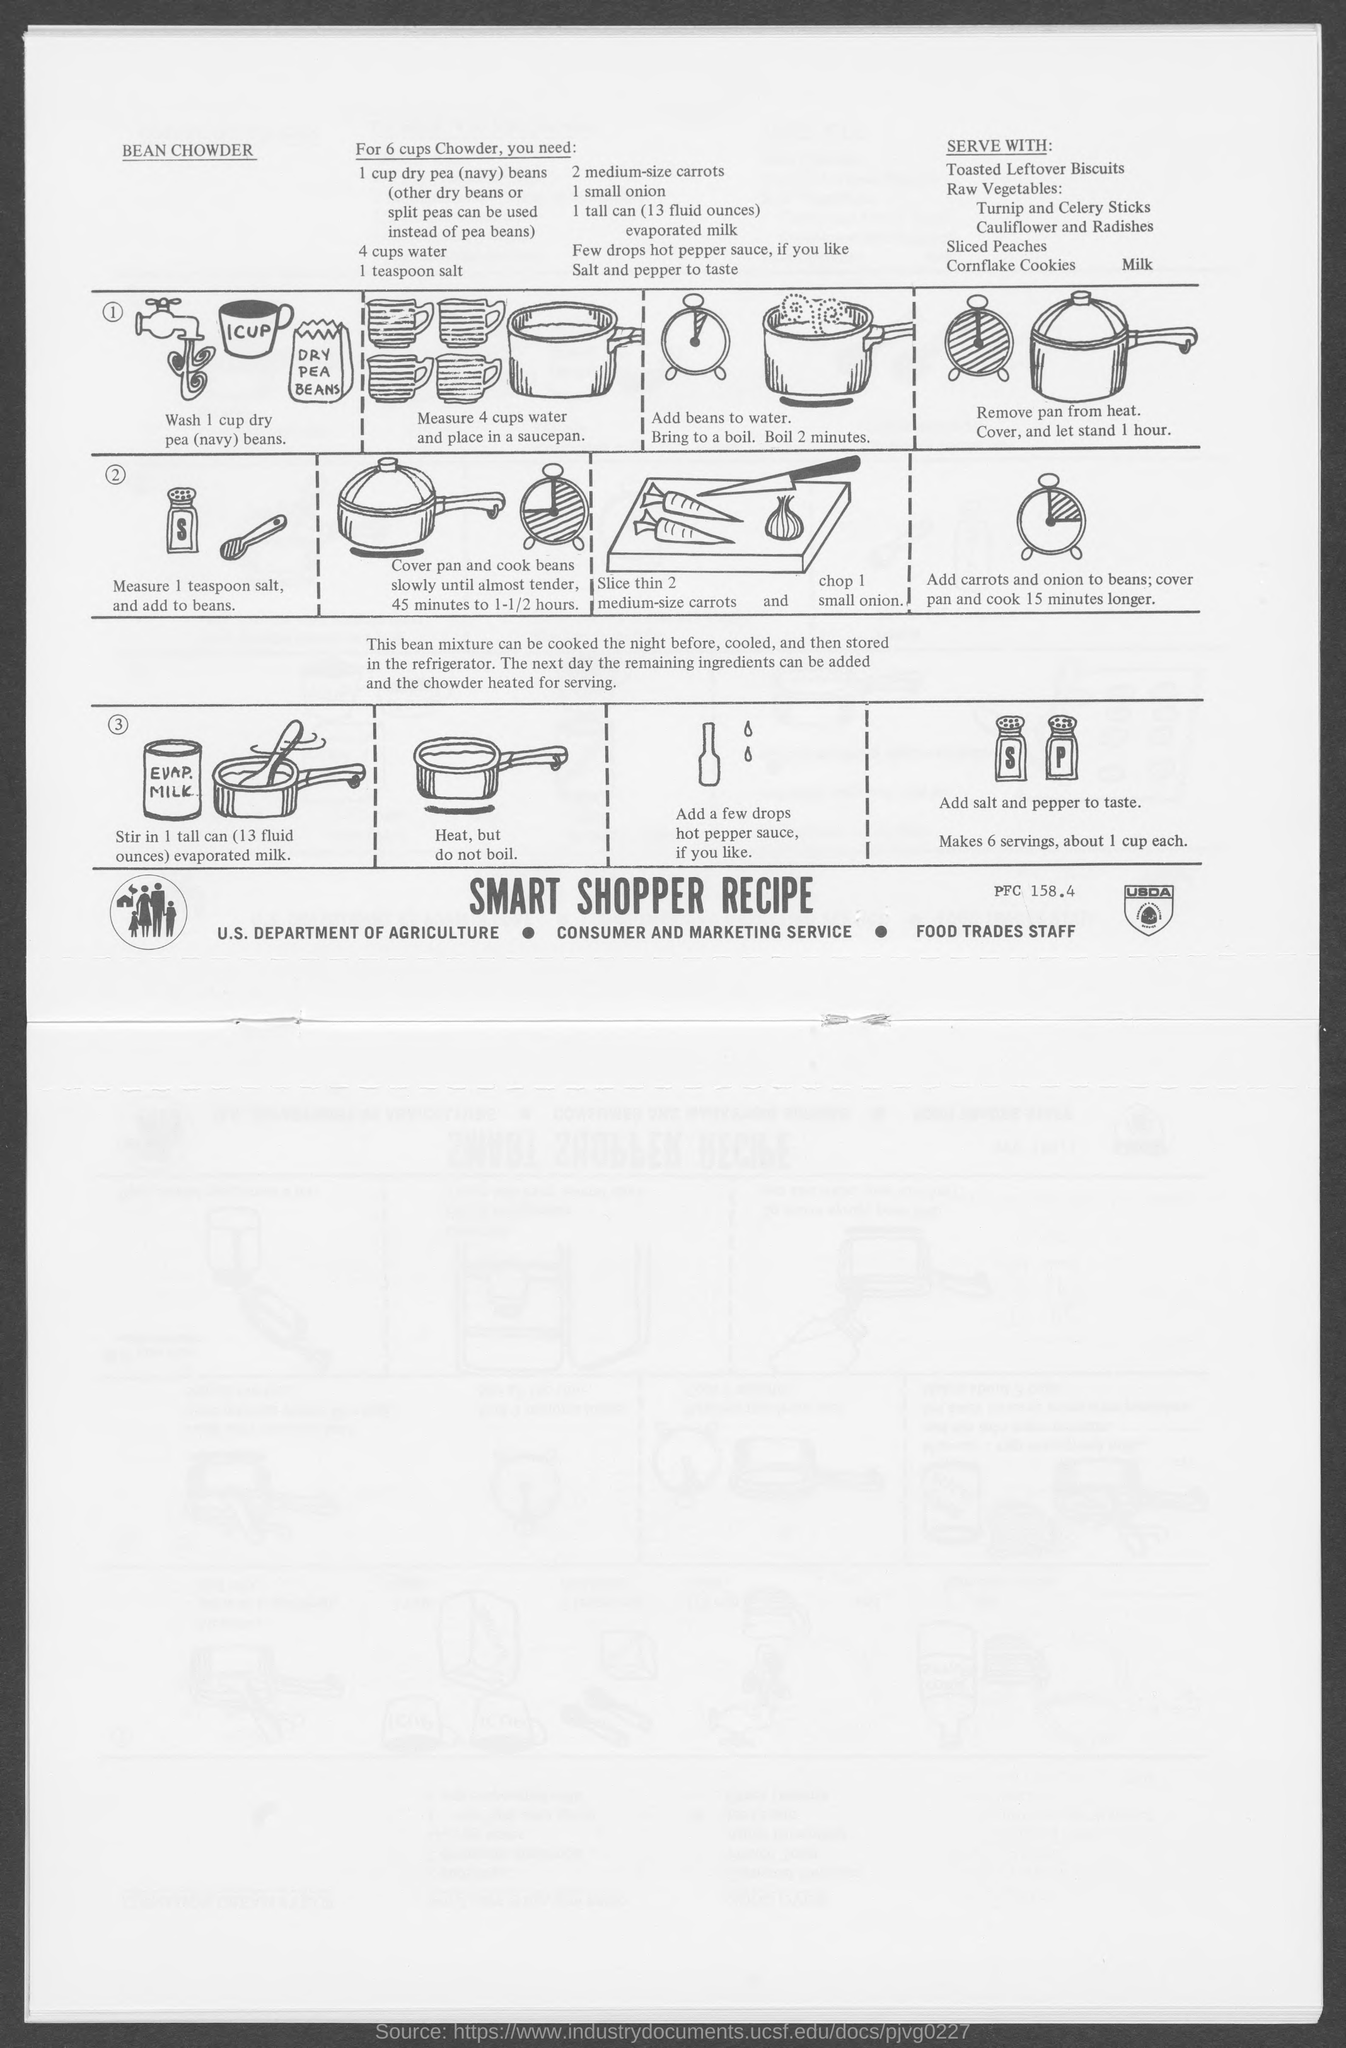Point out several critical features in this image. One cup of dry peas is required. I require one can of evaporated milk, please. Four cups of water are needed. I declare that the recipe I am searching for is for BEAN CHOWDER. 